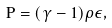<formula> <loc_0><loc_0><loc_500><loc_500>P = ( \gamma - 1 ) \rho \epsilon ,</formula> 